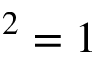<formula> <loc_0><loc_0><loc_500><loc_500>^ { 2 } = 1</formula> 